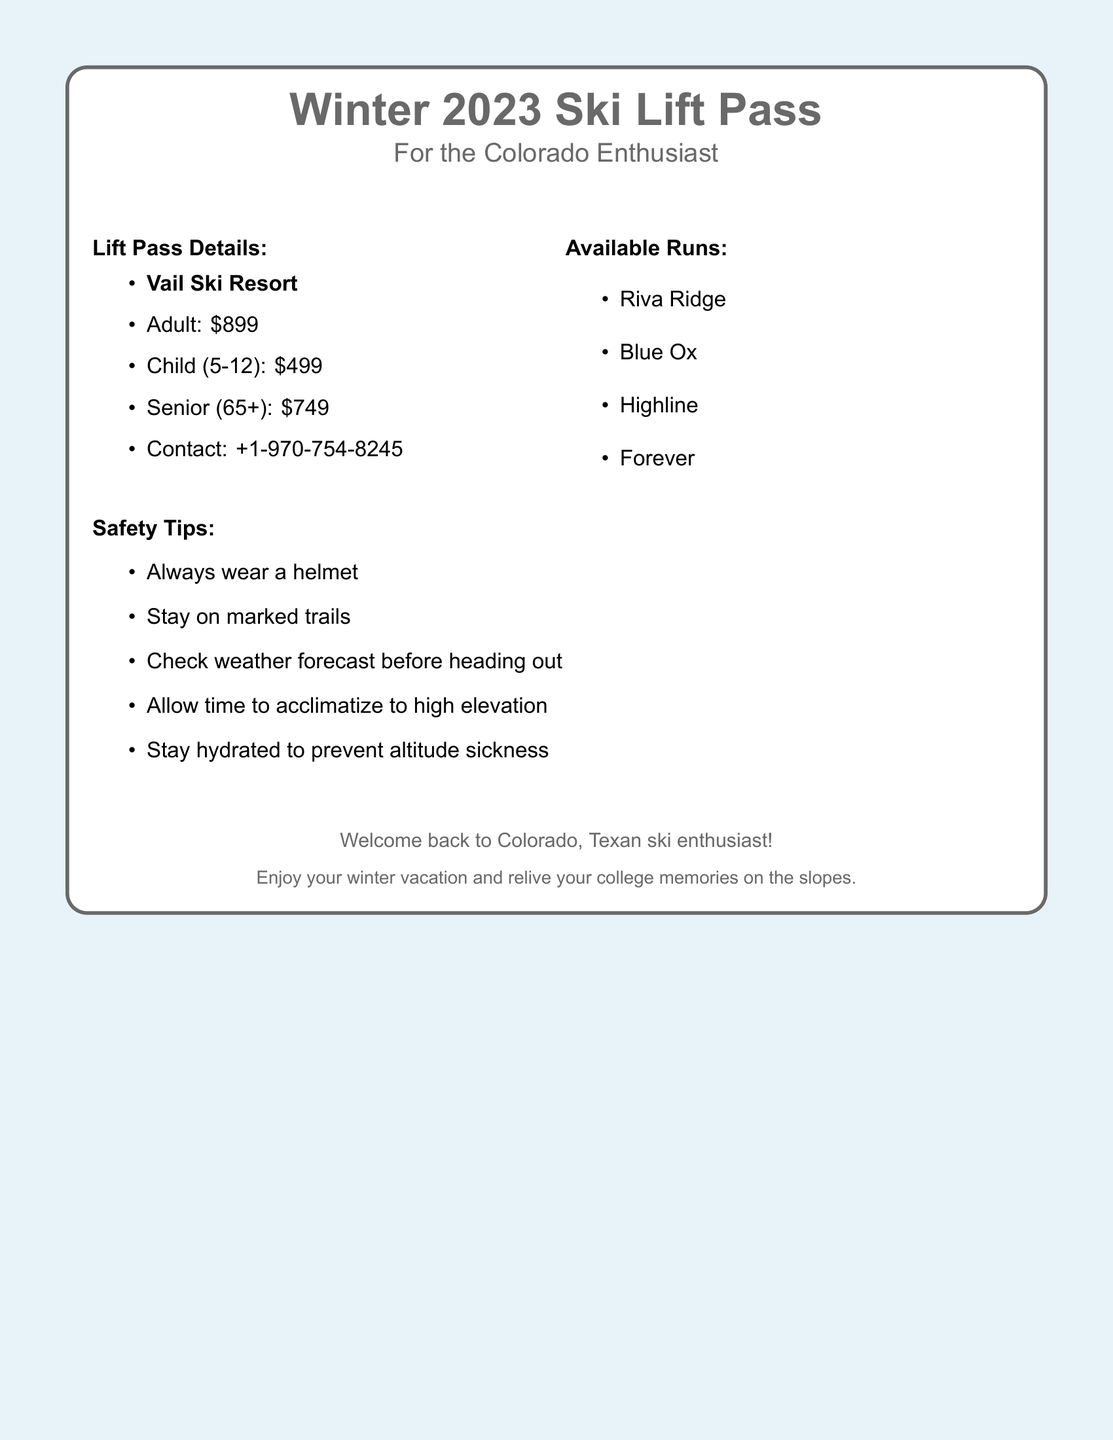What is the cost of an adult lift pass? The adult lift pass is priced at $899.
Answer: $899 What is the contact number for Vail Ski Resort? The contact number listed is +1-970-754-8245.
Answer: +1-970-754-8245 How much does a senior lift pass cost? The senior lift pass is priced at $749.
Answer: $749 Name one available run at Vail Ski Resort. One of the available runs is Riva Ridge.
Answer: Riva Ridge What should you do to prevent altitude sickness? Staying hydrated is recommended to prevent altitude sickness.
Answer: Stay hydrated How many total available runs are mentioned? There are four runs listed in the document.
Answer: Four What age range does the child lift pass cover? The child lift pass covers ages 5 to 12.
Answer: 5-12 What is the safety tip regarding trails? You should stay on marked trails for safety.
Answer: Stay on marked trails What is the theme of the document's message to the reader? The message welcomes back the Texan ski enthusiast to Colorado.
Answer: Welcome back to Colorado 